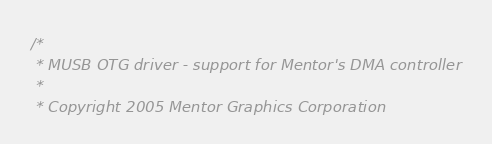Convert code to text. <code><loc_0><loc_0><loc_500><loc_500><_C_>/*
 * MUSB OTG driver - support for Mentor's DMA controller
 *
 * Copyright 2005 Mentor Graphics Corporation</code> 